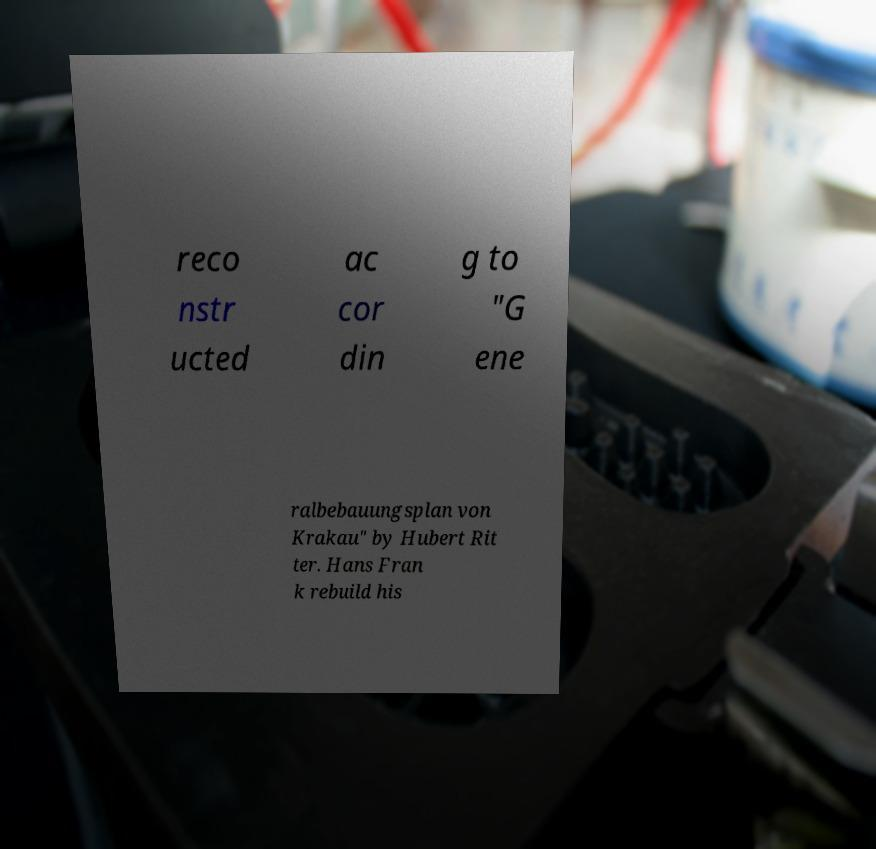For documentation purposes, I need the text within this image transcribed. Could you provide that? reco nstr ucted ac cor din g to "G ene ralbebauungsplan von Krakau" by Hubert Rit ter. Hans Fran k rebuild his 